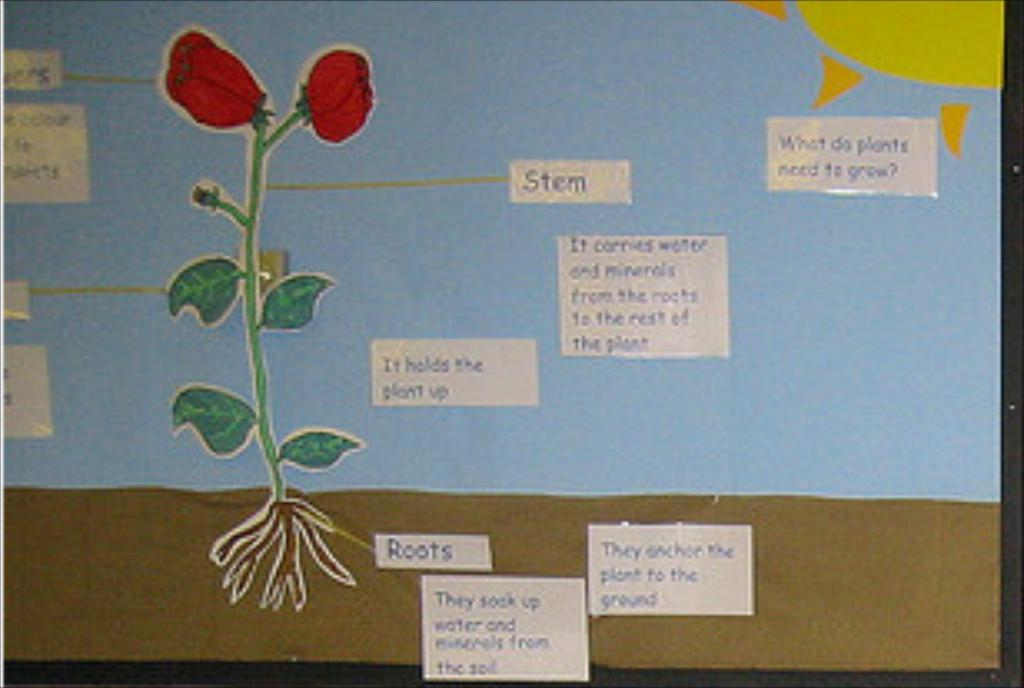What is the main object in the image? There is a board in the image. What is written or depicted on the board? The board contains text and figures. How many wings can be seen on the baby in the image? There is no baby present in the image, and therefore no wings can be seen. 